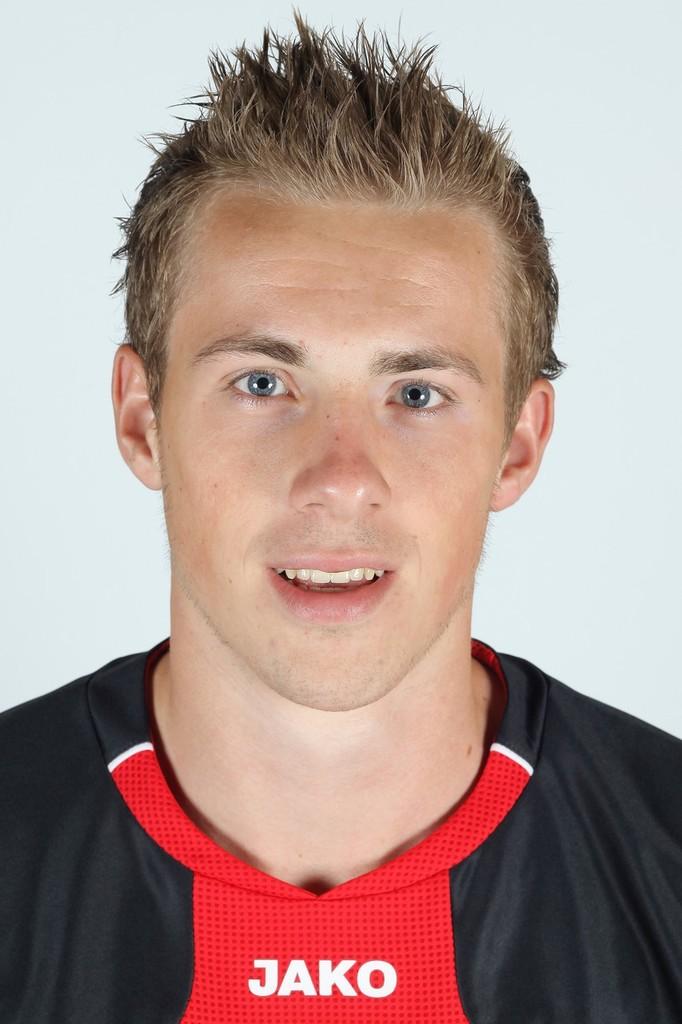Who makes that person's shirt?
Make the answer very short. Jako. 